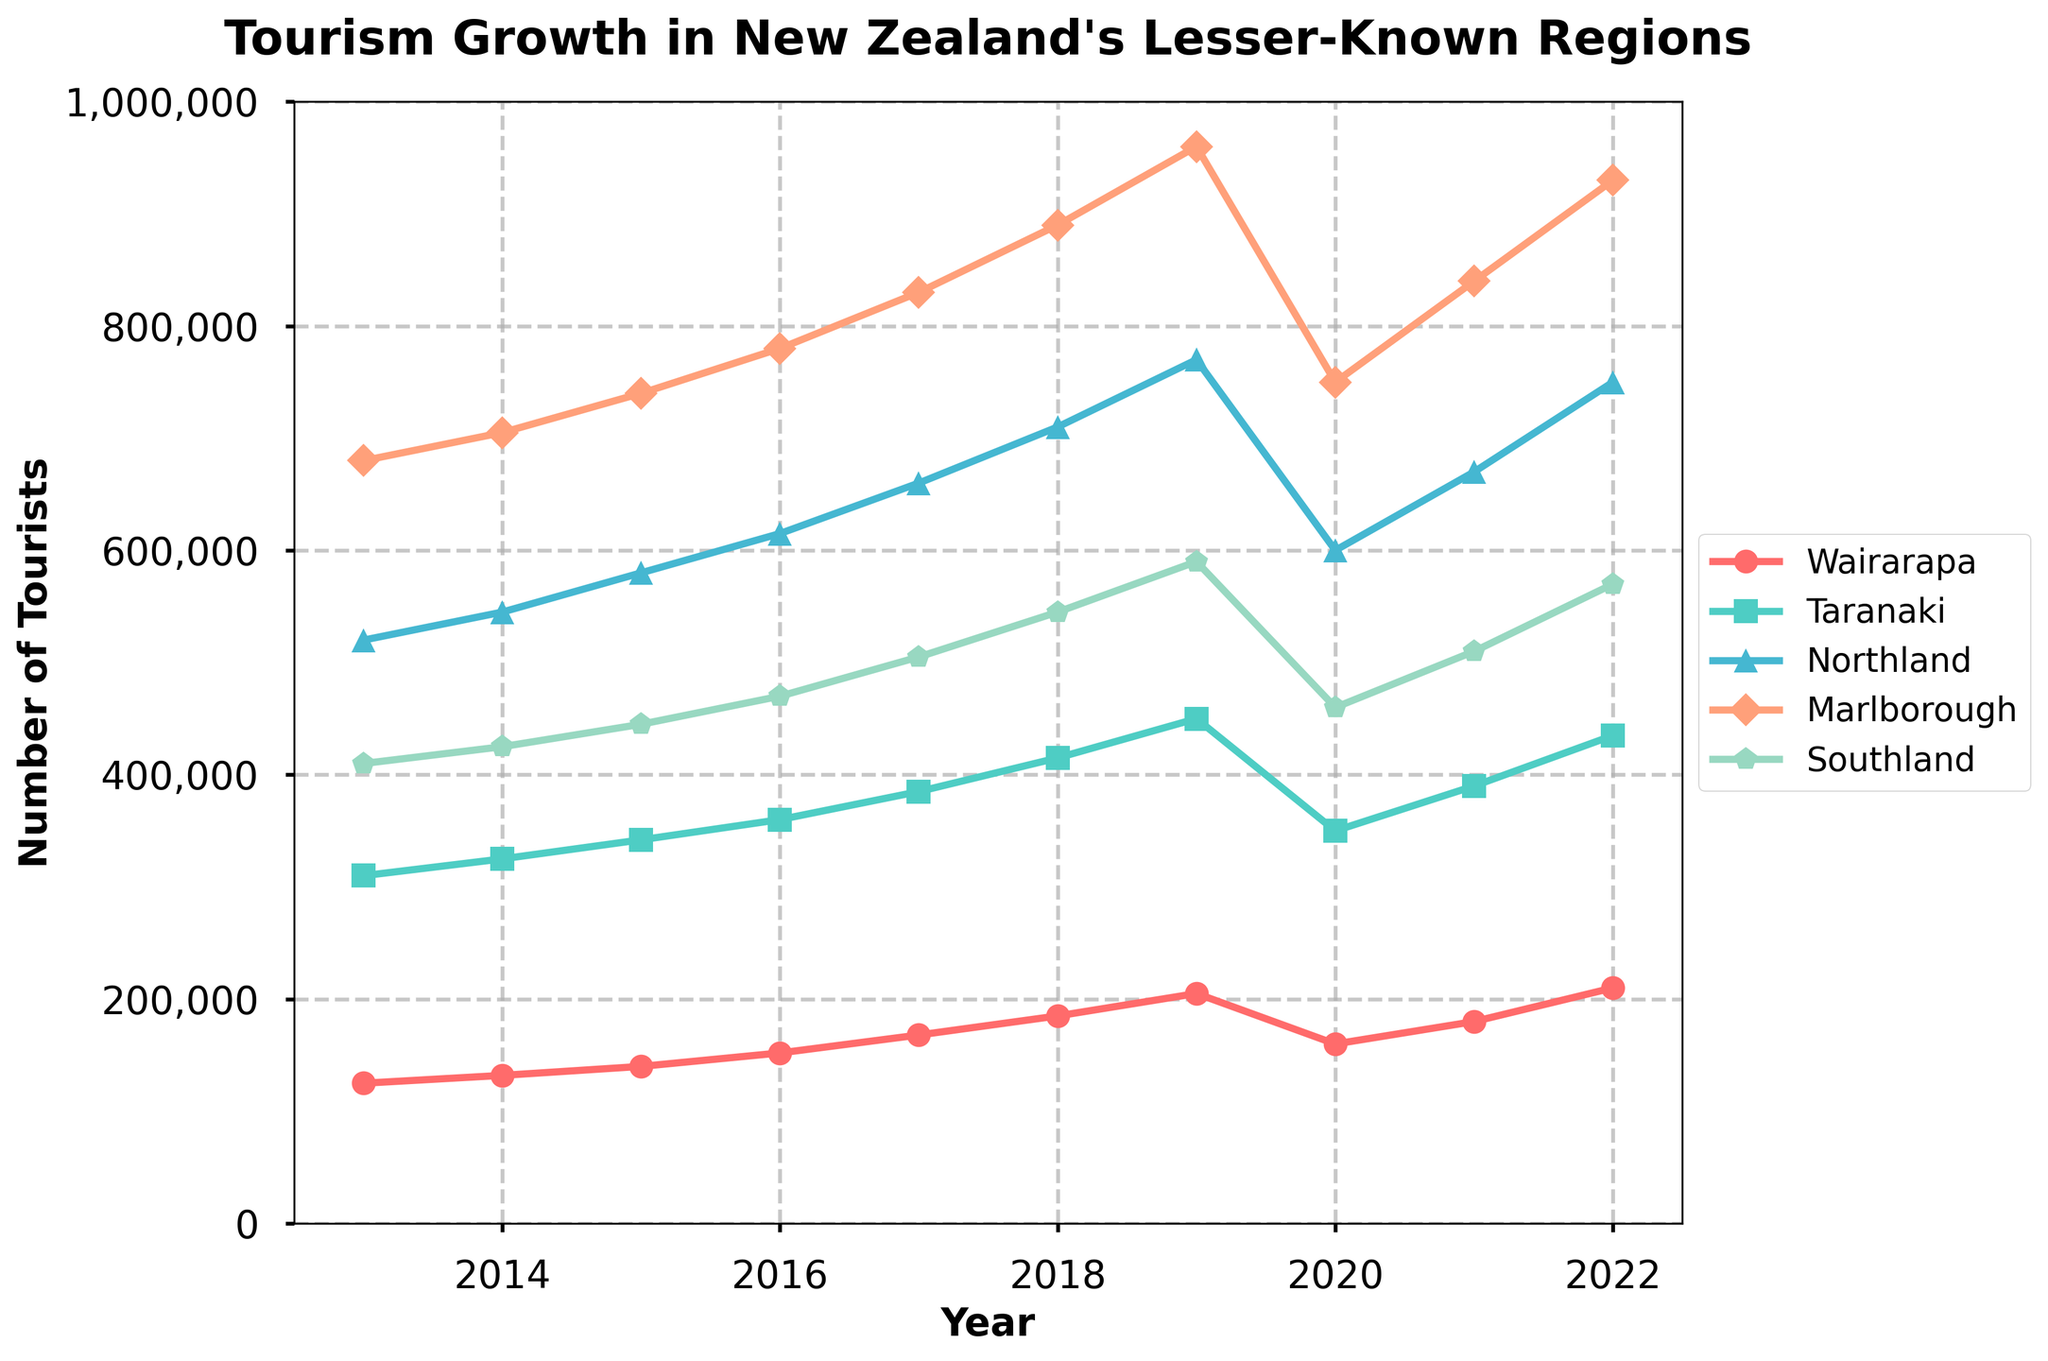Which region had the highest number of tourists in 2022? Look at the values for each region in the year 2022 and identify the highest value. Marlborough had 930,000 tourists, which is the highest.
Answer: Marlborough How did the number of tourists in Taranaki change from 2019 to 2020? Look at the values for Taranaki in 2019 (450,000) and in 2020 (350,000). Subtract the 2020 value from the 2019 value to find the change: 450,000 - 350,000 = 100,000.
Answer: Decreased by 100,000 Which year saw the biggest increase in tourists in Wairarapa? Identify the largest yearly increase by calculating the differences between consecutive years. The biggest increase is between 2018 and 2019: 205,000 - 185,000 = 20,000.
Answer: 2019 Compare the trends in Northland and Southland from 2013 to 2022. Which region had more consistent growth? Look at the slopes of the lines for Northland and Southland. Northland's growth is more consistent as it shows a more steady increase over the years, whereas Southland fluctuates more.
Answer: Northland In which year did Marlborough surpass 800,000 tourists for the first time? Check the Marlborough values year by year. Marlborough first surpassed 800,000 tourists in 2017 with 830,000.
Answer: 2017 What was the average number of tourists in Northland over the decade? Sum the tourist numbers for Northland from 2013 to 2022 and divide by the number of years (10). (520,000 + 545,000 + 580,000 + 615,000 + 660,000 + 710,000 + 770,000 + 600,000 + 670,000 + 750,000) / 10 = 642,000.
Answer: 642,000 Which region saw the smallest decrease in tourists in 2020 compared to 2019? Calculate the decrease for each region and compare. Wairarapa had a decrease of 45,000, which is the smallest among the regions.
Answer: Wairarapa Between Wairarapa, Taranaki, and Northland, which two regions had similar tourist numbers in 2015? Check the values for 2015: Wairarapa (140,000), Taranaki (342,000), Northland (580,000). None of these numbers are close to each other.
Answer: None Calculate the total number of tourists for Marlborough from 2013 to 2022. Sum the values of tourists for each year for Marlborough. 680,000 + 705,000 + 740,000 + 780,000 + 830,000 + 890,000 + 960,000 + 750,000 + 840,000 + 930,000 = 8,105,000.
Answer: 8,105,000 Which region had the highest growth rate between 2013 and 2022? Calculate the growth rate for each region: (final value - initial value) / initial value * 100. Marlborough: (930,000 - 680,000) / 680,000 * 100 ≈ 36.76%, Northland: (750,000 - 520,000) / 520,000 * 100 ≈ 44.23%, etc. The highest percentage growth is for Northland.
Answer: Northland 